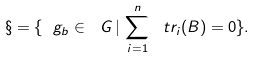Convert formula to latex. <formula><loc_0><loc_0><loc_500><loc_500>\S = \{ \ g _ { b } \in \ G \, | \, \sum _ { i = 1 } ^ { n } \ t r _ { i } ( B ) = 0 \} .</formula> 